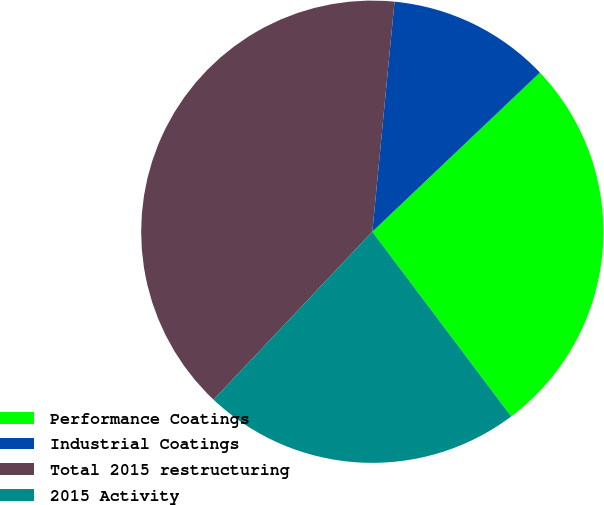<chart> <loc_0><loc_0><loc_500><loc_500><pie_chart><fcel>Performance Coatings<fcel>Industrial Coatings<fcel>Total 2015 restructuring<fcel>2015 Activity<nl><fcel>26.83%<fcel>11.38%<fcel>39.48%<fcel>22.31%<nl></chart> 